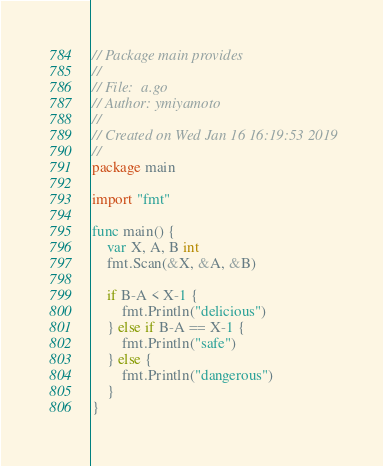<code> <loc_0><loc_0><loc_500><loc_500><_Go_>// Package main provides
//
// File:  a.go
// Author: ymiyamoto
//
// Created on Wed Jan 16 16:19:53 2019
//
package main

import "fmt"

func main() {
	var X, A, B int
	fmt.Scan(&X, &A, &B)

	if B-A < X-1 {
		fmt.Println("delicious")
	} else if B-A == X-1 {
		fmt.Println("safe")
	} else {
		fmt.Println("dangerous")
	}
}
</code> 